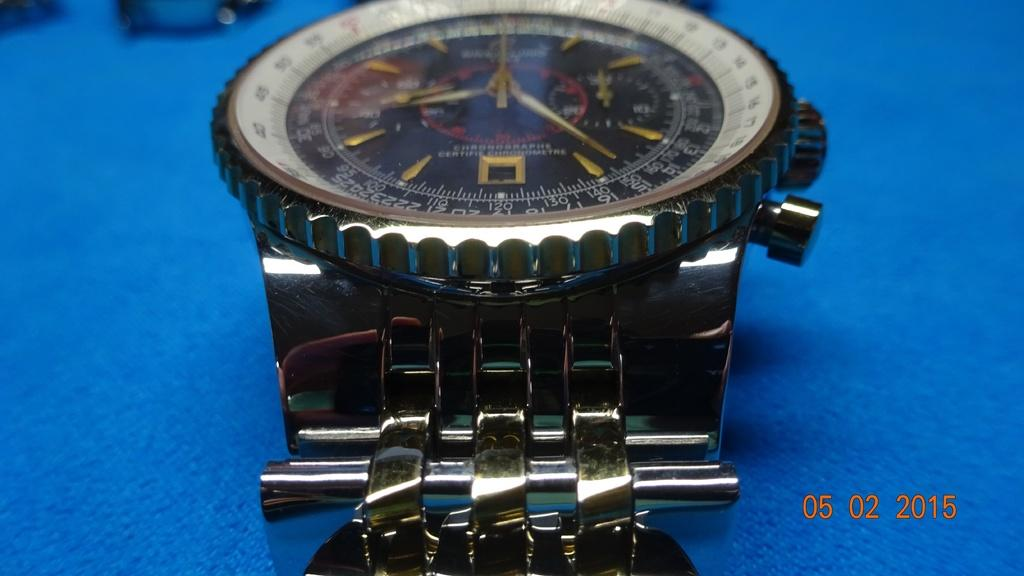<image>
Relay a brief, clear account of the picture shown. A photo of a watch on a blue surface that was taken in 2015. 